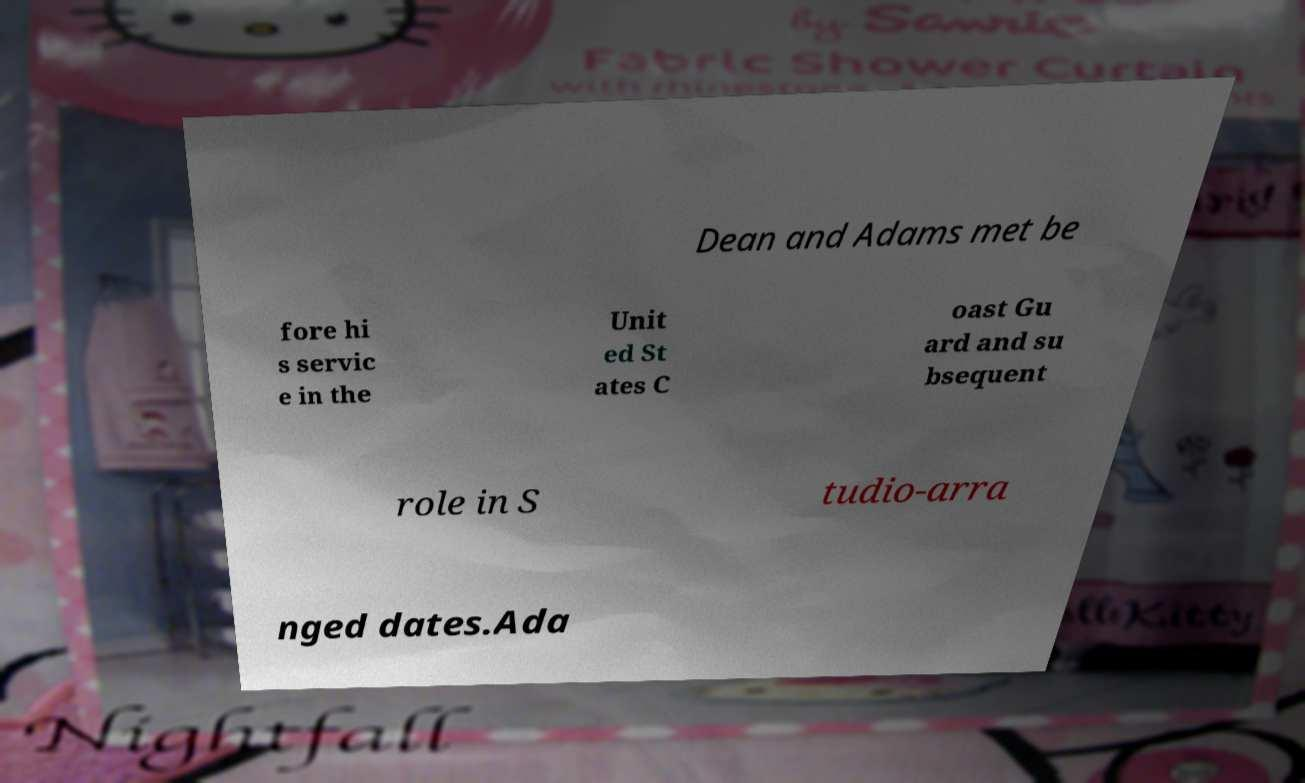Could you extract and type out the text from this image? Dean and Adams met be fore hi s servic e in the Unit ed St ates C oast Gu ard and su bsequent role in S tudio-arra nged dates.Ada 